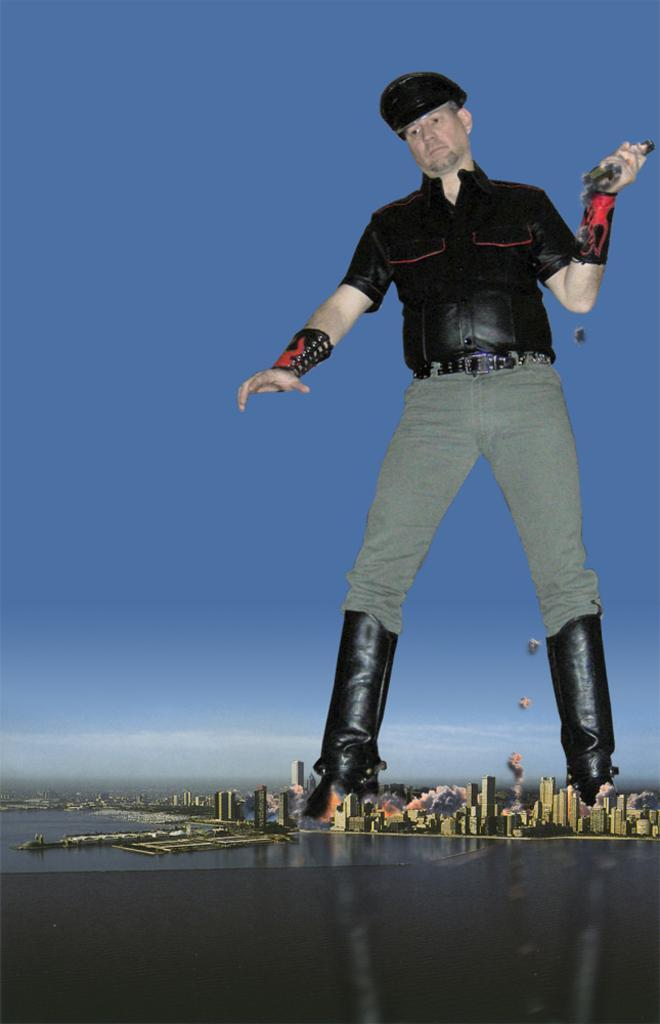How would you summarize this image in a sentence or two? In this picture we can see a man holding an object with his hand and standing on the ground, water, buildings and some objects and in the background we can see the sky. 